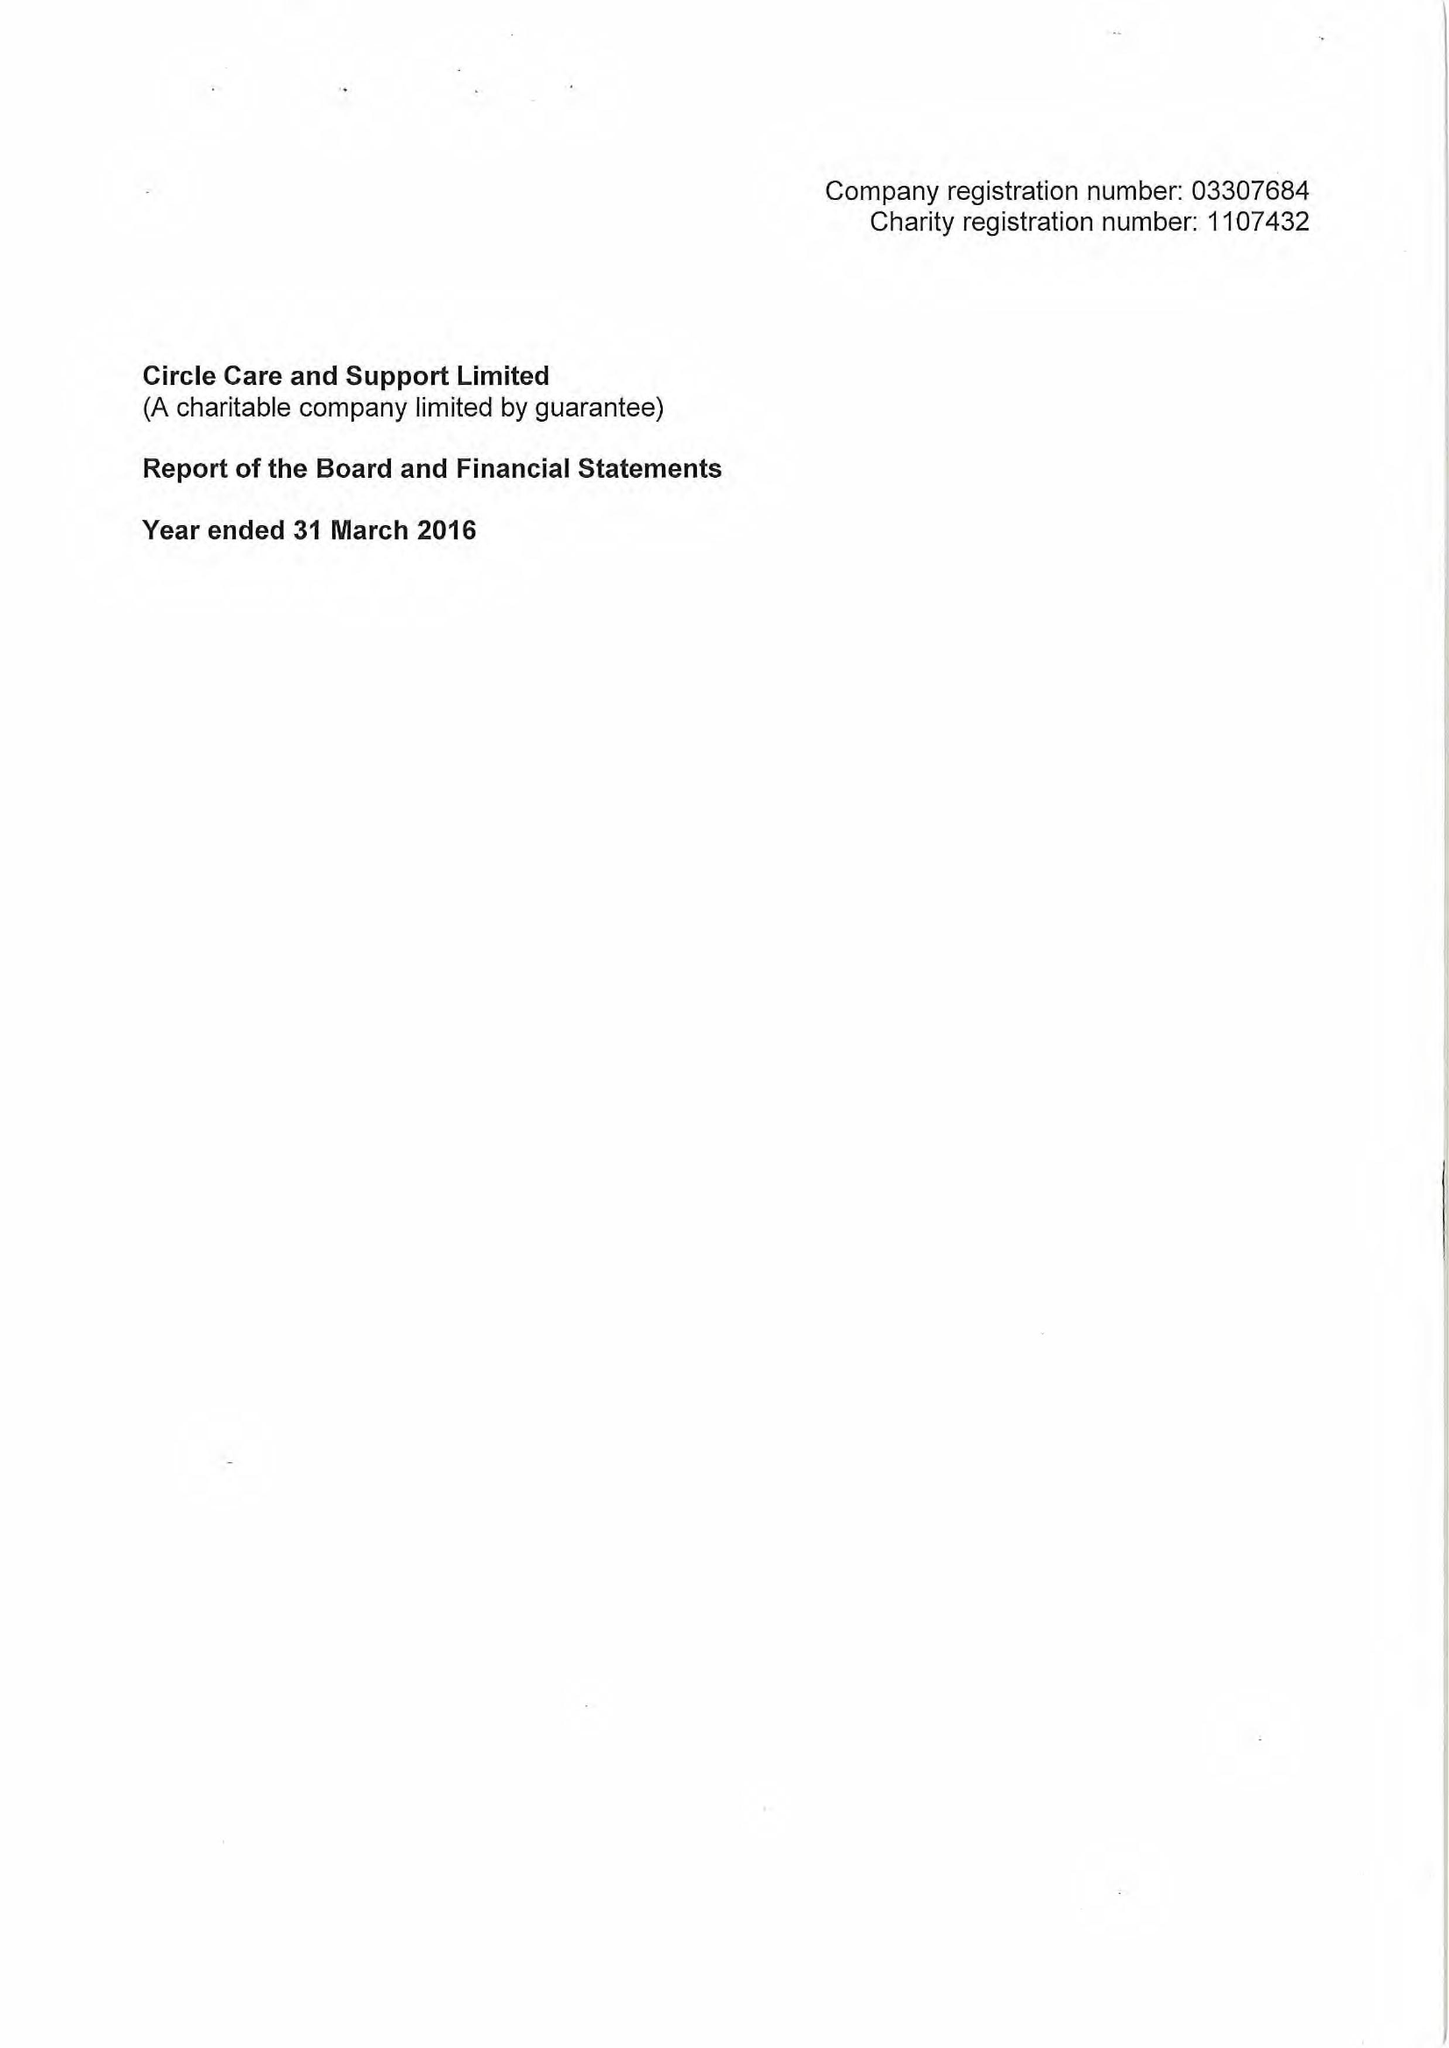What is the value for the report_date?
Answer the question using a single word or phrase. 2016-03-31 